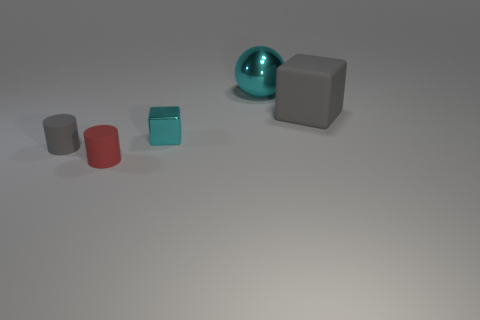Subtract all yellow cylinders. How many gray cubes are left? 1 Subtract all red rubber objects. Subtract all small red metal objects. How many objects are left? 4 Add 5 blocks. How many blocks are left? 7 Add 3 shiny spheres. How many shiny spheres exist? 4 Add 3 cyan objects. How many objects exist? 8 Subtract all red cylinders. How many cylinders are left? 1 Subtract 0 brown blocks. How many objects are left? 5 Subtract all balls. How many objects are left? 4 Subtract all cyan cylinders. Subtract all purple blocks. How many cylinders are left? 2 